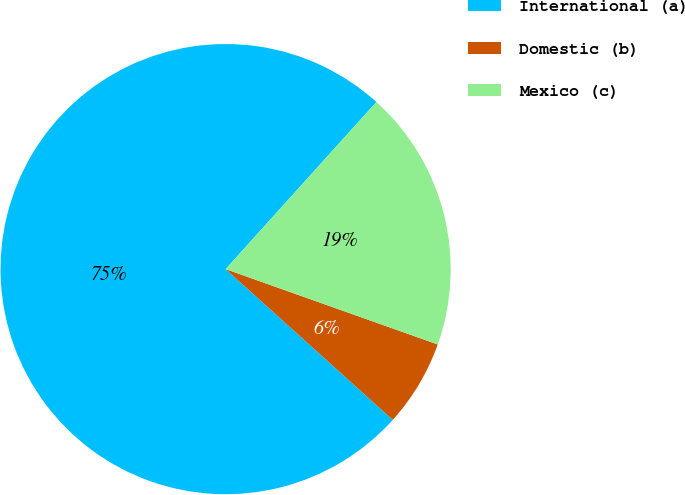<chart> <loc_0><loc_0><loc_500><loc_500><pie_chart><fcel>International (a)<fcel>Domestic (b)<fcel>Mexico (c)<nl><fcel>75.0%<fcel>6.25%<fcel>18.75%<nl></chart> 